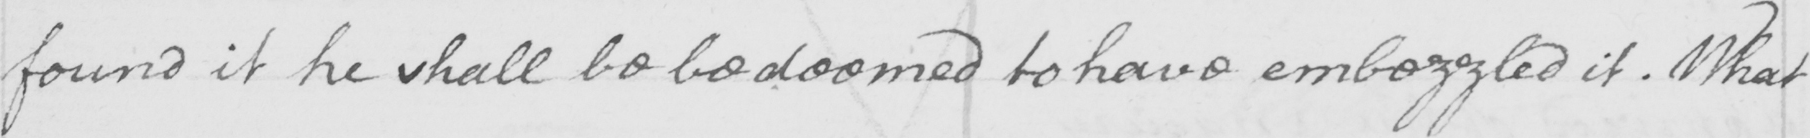Please provide the text content of this handwritten line. found it he shall be be deemed to have embezzled it . What 